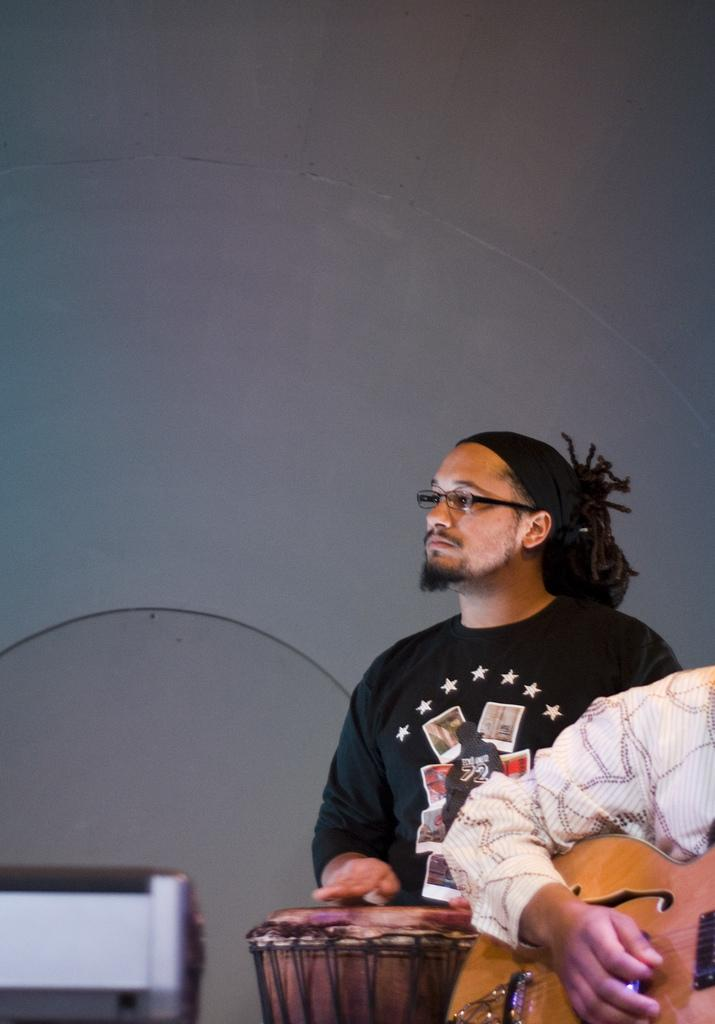What is the man in the image doing? The man is standing and playing the drum in the image. Who is the man looking at? The man is staring at someone in the image. What is the other person in the image doing? The other person is playing the guitar in the image. What type of mine is visible in the image? There is no mine present in the image. What dish is being served on the plate in the image? There is no plate or dish visible in the image. 